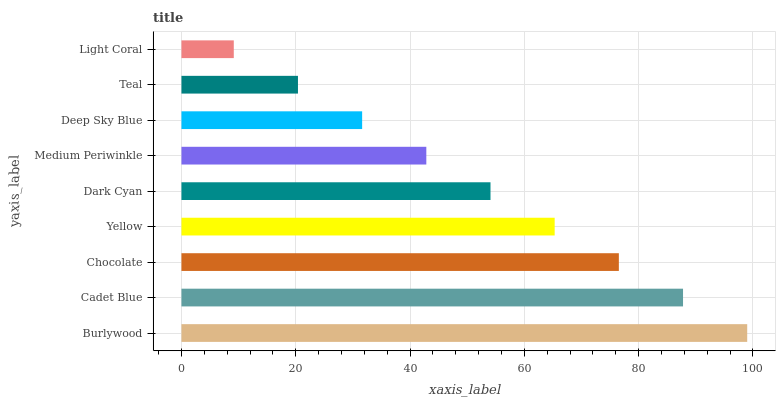Is Light Coral the minimum?
Answer yes or no. Yes. Is Burlywood the maximum?
Answer yes or no. Yes. Is Cadet Blue the minimum?
Answer yes or no. No. Is Cadet Blue the maximum?
Answer yes or no. No. Is Burlywood greater than Cadet Blue?
Answer yes or no. Yes. Is Cadet Blue less than Burlywood?
Answer yes or no. Yes. Is Cadet Blue greater than Burlywood?
Answer yes or no. No. Is Burlywood less than Cadet Blue?
Answer yes or no. No. Is Dark Cyan the high median?
Answer yes or no. Yes. Is Dark Cyan the low median?
Answer yes or no. Yes. Is Deep Sky Blue the high median?
Answer yes or no. No. Is Yellow the low median?
Answer yes or no. No. 